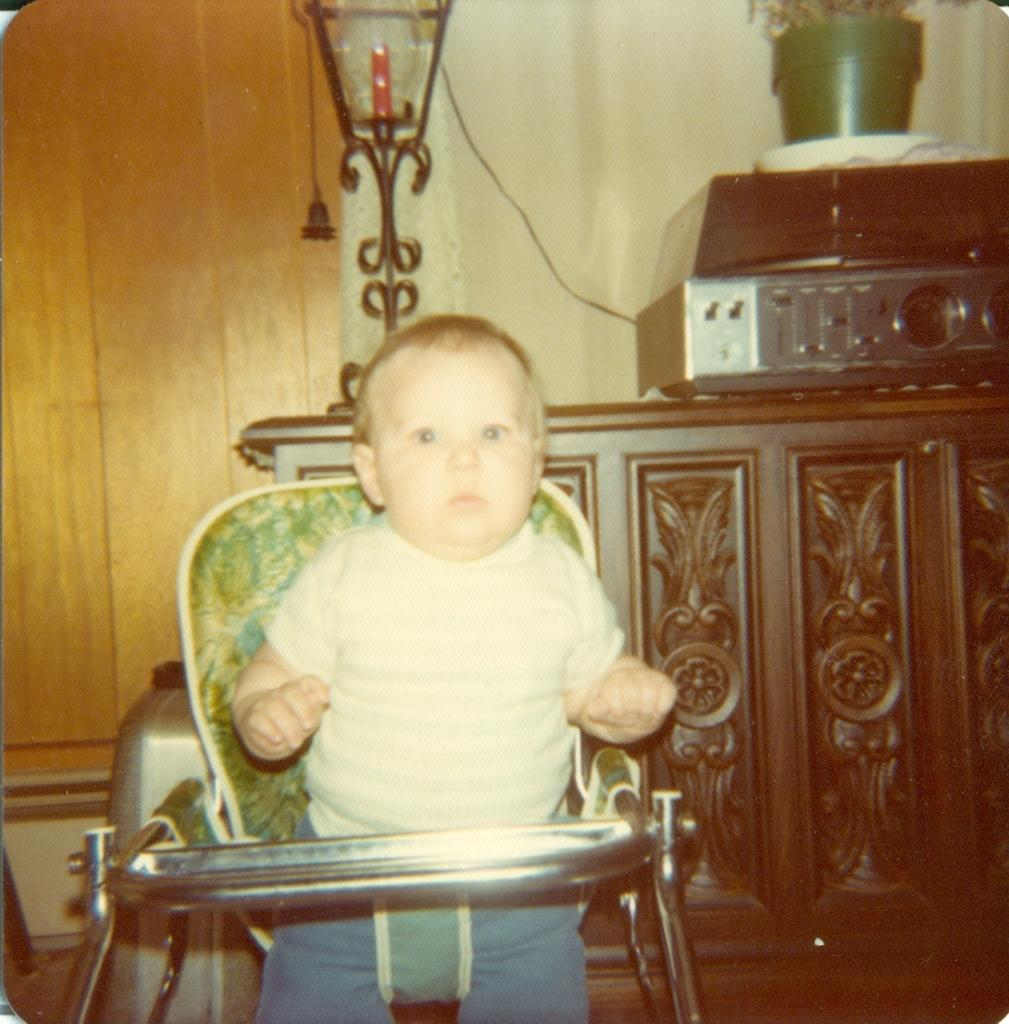What is the main subject of the image? The main subject of the image is a kid. What is the kid wearing? The kid is wearing a white dress. What activity is the kid engaged in? The kid is playing with a toy vehicle. What can be seen in the background of the image? There is a lamp in the background of the image. How many dogs are present in the image? There are no dogs present in the image. What type of pail is the kid using to play with the toy vehicle? There is no pail visible in the image; the kid is playing with a toy vehicle. 